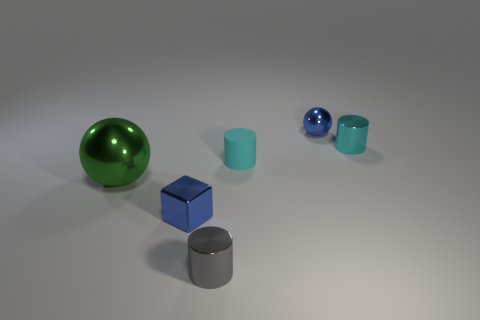There is a blue ball behind the metal cylinder behind the big green shiny object; is there a tiny gray shiny cylinder that is on the right side of it?
Ensure brevity in your answer.  No. The metal cube has what color?
Your answer should be very brief. Blue. Are there any cyan metallic things to the right of the cyan metallic cylinder?
Provide a succinct answer. No. There is a tiny cyan shiny object; is its shape the same as the small metal thing that is on the left side of the gray metal cylinder?
Your response must be concise. No. How many other objects are the same material as the small blue ball?
Give a very brief answer. 4. What is the color of the sphere that is to the right of the blue thing that is in front of the metallic sphere behind the big green thing?
Offer a terse response. Blue. What is the shape of the small cyan object that is to the left of the small cyan metallic thing behind the metallic block?
Offer a very short reply. Cylinder. Is the number of small shiny balls that are behind the blue metallic ball greater than the number of shiny blocks?
Give a very brief answer. No. There is a green object that is on the left side of the tiny gray cylinder; does it have the same shape as the small gray thing?
Offer a very short reply. No. Are there any other gray metal things that have the same shape as the tiny gray object?
Provide a short and direct response. No. 